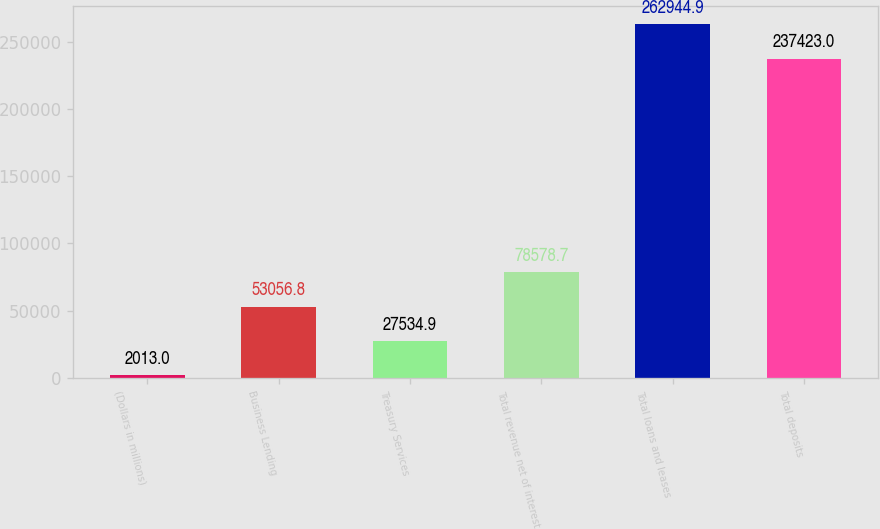Convert chart. <chart><loc_0><loc_0><loc_500><loc_500><bar_chart><fcel>(Dollars in millions)<fcel>Business Lending<fcel>Treasury Services<fcel>Total revenue net of interest<fcel>Total loans and leases<fcel>Total deposits<nl><fcel>2013<fcel>53056.8<fcel>27534.9<fcel>78578.7<fcel>262945<fcel>237423<nl></chart> 